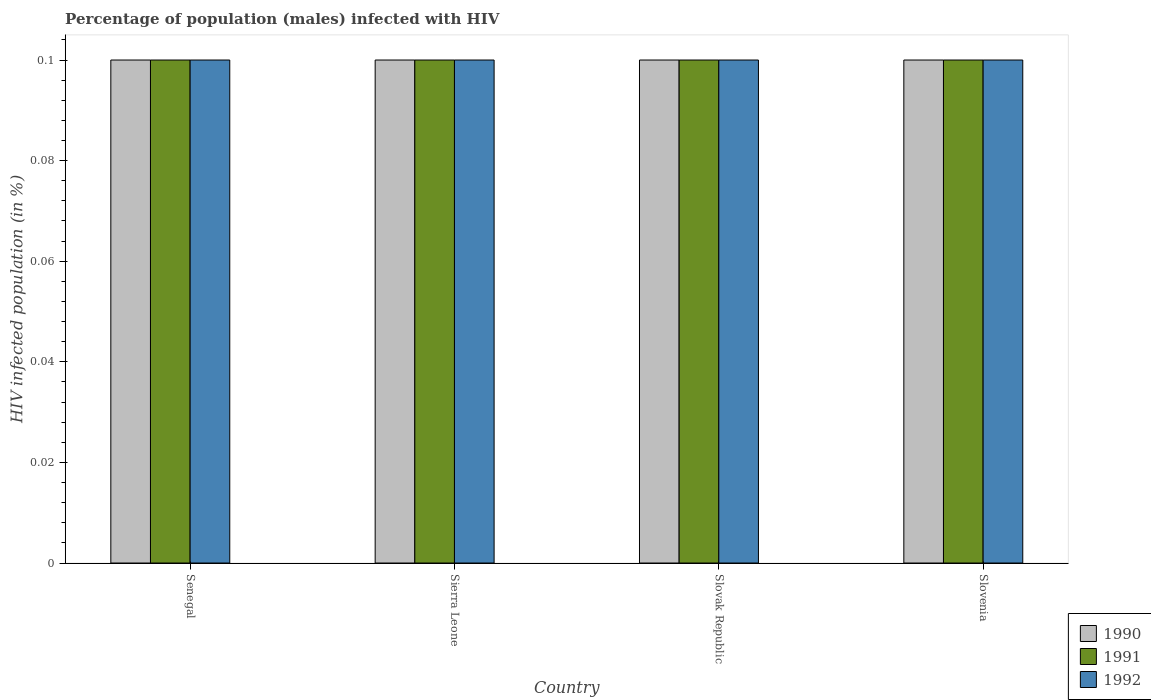How many different coloured bars are there?
Keep it short and to the point. 3. Are the number of bars per tick equal to the number of legend labels?
Ensure brevity in your answer.  Yes. How many bars are there on the 3rd tick from the left?
Your answer should be compact. 3. What is the label of the 1st group of bars from the left?
Offer a terse response. Senegal. In how many cases, is the number of bars for a given country not equal to the number of legend labels?
Provide a short and direct response. 0. What is the percentage of HIV infected male population in 1991 in Sierra Leone?
Your response must be concise. 0.1. Across all countries, what is the minimum percentage of HIV infected male population in 1992?
Keep it short and to the point. 0.1. In which country was the percentage of HIV infected male population in 1990 maximum?
Your answer should be compact. Senegal. In which country was the percentage of HIV infected male population in 1990 minimum?
Offer a very short reply. Senegal. What is the total percentage of HIV infected male population in 1991 in the graph?
Make the answer very short. 0.4. Is the percentage of HIV infected male population in 1992 in Senegal less than that in Slovenia?
Offer a terse response. No. What is the difference between the highest and the lowest percentage of HIV infected male population in 1992?
Your response must be concise. 0. Is the sum of the percentage of HIV infected male population in 1990 in Senegal and Slovak Republic greater than the maximum percentage of HIV infected male population in 1992 across all countries?
Offer a very short reply. Yes. What does the 2nd bar from the left in Senegal represents?
Offer a terse response. 1991. What does the 3rd bar from the right in Slovak Republic represents?
Give a very brief answer. 1990. Is it the case that in every country, the sum of the percentage of HIV infected male population in 1990 and percentage of HIV infected male population in 1992 is greater than the percentage of HIV infected male population in 1991?
Provide a short and direct response. Yes. Does the graph contain any zero values?
Keep it short and to the point. No. Does the graph contain grids?
Offer a terse response. No. Where does the legend appear in the graph?
Provide a succinct answer. Bottom right. How many legend labels are there?
Provide a succinct answer. 3. What is the title of the graph?
Ensure brevity in your answer.  Percentage of population (males) infected with HIV. Does "1960" appear as one of the legend labels in the graph?
Your answer should be compact. No. What is the label or title of the X-axis?
Offer a terse response. Country. What is the label or title of the Y-axis?
Offer a very short reply. HIV infected population (in %). What is the HIV infected population (in %) in 1991 in Slovenia?
Offer a very short reply. 0.1. What is the HIV infected population (in %) of 1992 in Slovenia?
Give a very brief answer. 0.1. Across all countries, what is the maximum HIV infected population (in %) of 1990?
Provide a succinct answer. 0.1. Across all countries, what is the maximum HIV infected population (in %) of 1991?
Your response must be concise. 0.1. Across all countries, what is the minimum HIV infected population (in %) in 1990?
Offer a terse response. 0.1. Across all countries, what is the minimum HIV infected population (in %) in 1991?
Keep it short and to the point. 0.1. Across all countries, what is the minimum HIV infected population (in %) in 1992?
Make the answer very short. 0.1. What is the total HIV infected population (in %) in 1991 in the graph?
Provide a short and direct response. 0.4. What is the total HIV infected population (in %) in 1992 in the graph?
Make the answer very short. 0.4. What is the difference between the HIV infected population (in %) in 1990 in Senegal and that in Sierra Leone?
Keep it short and to the point. 0. What is the difference between the HIV infected population (in %) of 1992 in Senegal and that in Slovak Republic?
Your response must be concise. 0. What is the difference between the HIV infected population (in %) of 1990 in Sierra Leone and that in Slovak Republic?
Provide a succinct answer. 0. What is the difference between the HIV infected population (in %) of 1992 in Sierra Leone and that in Slovak Republic?
Provide a succinct answer. 0. What is the difference between the HIV infected population (in %) of 1991 in Sierra Leone and that in Slovenia?
Your answer should be compact. 0. What is the difference between the HIV infected population (in %) of 1990 in Slovak Republic and that in Slovenia?
Keep it short and to the point. 0. What is the difference between the HIV infected population (in %) in 1991 in Slovak Republic and that in Slovenia?
Keep it short and to the point. 0. What is the difference between the HIV infected population (in %) of 1990 in Senegal and the HIV infected population (in %) of 1992 in Slovak Republic?
Offer a terse response. 0. What is the difference between the HIV infected population (in %) in 1990 in Senegal and the HIV infected population (in %) in 1991 in Slovenia?
Keep it short and to the point. 0. What is the difference between the HIV infected population (in %) in 1991 in Senegal and the HIV infected population (in %) in 1992 in Slovenia?
Offer a terse response. 0. What is the difference between the HIV infected population (in %) of 1990 in Sierra Leone and the HIV infected population (in %) of 1992 in Slovak Republic?
Your answer should be compact. 0. What is the difference between the HIV infected population (in %) in 1990 in Sierra Leone and the HIV infected population (in %) in 1992 in Slovenia?
Your response must be concise. 0. What is the difference between the HIV infected population (in %) of 1991 in Slovak Republic and the HIV infected population (in %) of 1992 in Slovenia?
Provide a short and direct response. 0. What is the average HIV infected population (in %) in 1991 per country?
Give a very brief answer. 0.1. What is the average HIV infected population (in %) of 1992 per country?
Make the answer very short. 0.1. What is the difference between the HIV infected population (in %) in 1990 and HIV infected population (in %) in 1991 in Senegal?
Offer a terse response. 0. What is the difference between the HIV infected population (in %) in 1990 and HIV infected population (in %) in 1992 in Sierra Leone?
Offer a terse response. 0. What is the difference between the HIV infected population (in %) of 1991 and HIV infected population (in %) of 1992 in Sierra Leone?
Provide a succinct answer. 0. What is the difference between the HIV infected population (in %) of 1990 and HIV infected population (in %) of 1991 in Slovak Republic?
Provide a short and direct response. 0. What is the difference between the HIV infected population (in %) of 1990 and HIV infected population (in %) of 1992 in Slovak Republic?
Offer a terse response. 0. What is the difference between the HIV infected population (in %) of 1991 and HIV infected population (in %) of 1992 in Slovak Republic?
Offer a terse response. 0. What is the difference between the HIV infected population (in %) in 1990 and HIV infected population (in %) in 1991 in Slovenia?
Ensure brevity in your answer.  0. What is the difference between the HIV infected population (in %) of 1991 and HIV infected population (in %) of 1992 in Slovenia?
Offer a very short reply. 0. What is the ratio of the HIV infected population (in %) of 1991 in Senegal to that in Slovenia?
Offer a very short reply. 1. What is the ratio of the HIV infected population (in %) in 1990 in Sierra Leone to that in Slovak Republic?
Ensure brevity in your answer.  1. What is the ratio of the HIV infected population (in %) in 1990 in Sierra Leone to that in Slovenia?
Make the answer very short. 1. What is the ratio of the HIV infected population (in %) of 1991 in Slovak Republic to that in Slovenia?
Provide a short and direct response. 1. What is the ratio of the HIV infected population (in %) of 1992 in Slovak Republic to that in Slovenia?
Ensure brevity in your answer.  1. 